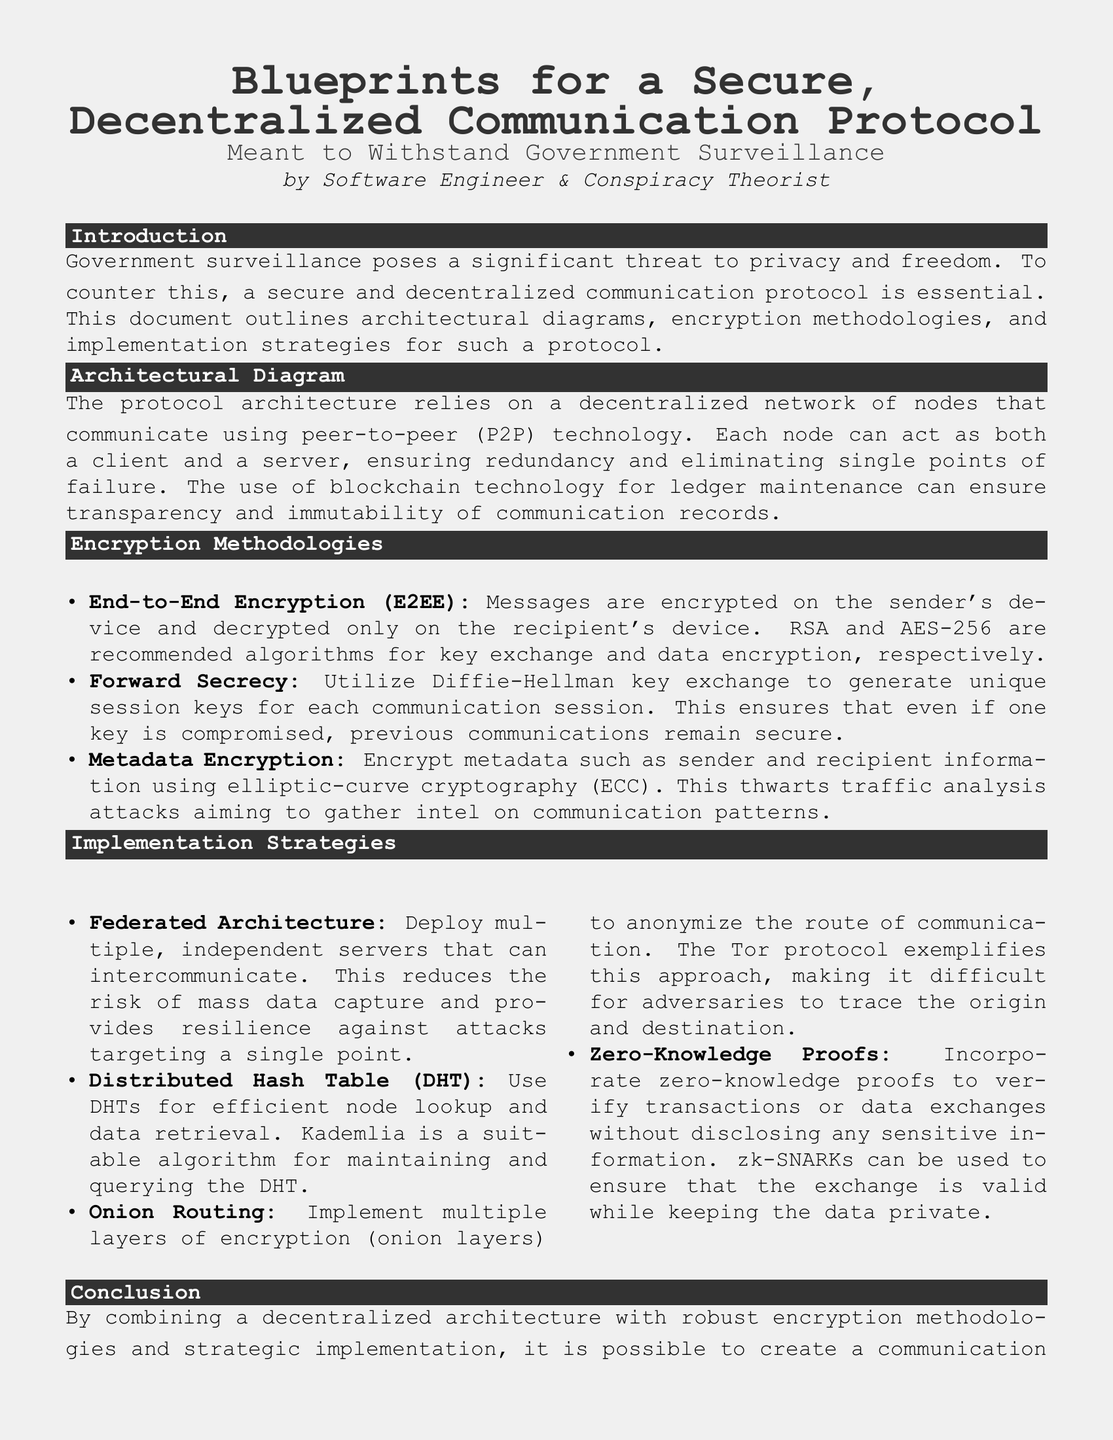What is the title of the document? The title of the document is prominently displayed at the top, summarizing its focus and intent.
Answer: Blueprints for a Secure, Decentralized Communication Protocol Who is the author of the document? The document credits an author identified at the center of the first page, denoting their role and interests.
Answer: Software Engineer & Conspiracy Theorist What encryption algorithms are recommended for data encryption? The document specifies recommended algorithms for data encryption and key exchange in the encryption methodologies section.
Answer: AES-256 What type of architecture does the protocol rely on? The architectural details highlight the fundamental structure that supports the protocol's operations, described in the architectural diagram section.
Answer: Decentralized network What is used to ensure transparency and immutability of communication records? The document mentions a technology that guarantees communication records are not altered and are publicly verifiable.
Answer: Blockchain technology How does the protocol ensure that previous communications remain secure even if a key is compromised? Reasoning through the encryption section reveals a method employed to generate unique keys for enhancing security.
Answer: Forward Secrecy What is the purpose of zero-knowledge proofs in the protocol? The document details the function of zero-knowledge proofs within the implementation strategies, especially concerning data validation.
Answer: Verify transactions without disclosing sensitive information What routing method is mentioned for anonymizing communication? The implementation strategies list a specific method used to obscure the path of communication to protect user identities and data.
Answer: Onion Routing How many servers does the federated architecture suggest deploying? The document suggests multiple servers but does not specify a number, indicating a concept rather than a fixed quantity.
Answer: Multiple 